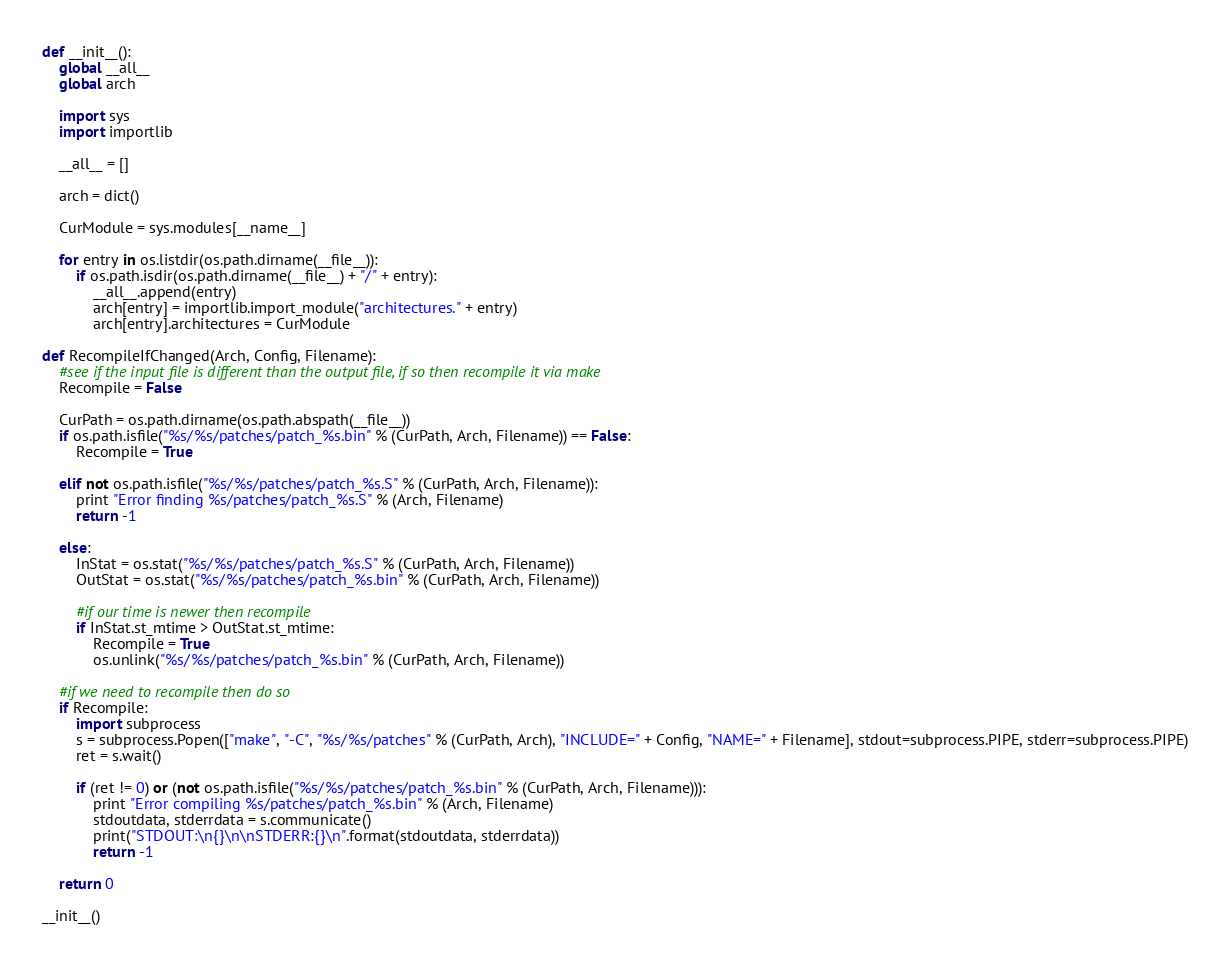Convert code to text. <code><loc_0><loc_0><loc_500><loc_500><_Python_>
def __init__():
    global __all__
    global arch

    import sys
    import importlib

    __all__ = []

    arch = dict()

    CurModule = sys.modules[__name__]

    for entry in os.listdir(os.path.dirname(__file__)):
        if os.path.isdir(os.path.dirname(__file__) + "/" + entry):
            __all__.append(entry)
            arch[entry] = importlib.import_module("architectures." + entry)
            arch[entry].architectures = CurModule

def RecompileIfChanged(Arch, Config, Filename):
    #see if the input file is different than the output file, if so then recompile it via make
    Recompile = False

    CurPath = os.path.dirname(os.path.abspath(__file__))
    if os.path.isfile("%s/%s/patches/patch_%s.bin" % (CurPath, Arch, Filename)) == False:
        Recompile = True

    elif not os.path.isfile("%s/%s/patches/patch_%s.S" % (CurPath, Arch, Filename)):
        print "Error finding %s/patches/patch_%s.S" % (Arch, Filename)
        return -1

    else:
        InStat = os.stat("%s/%s/patches/patch_%s.S" % (CurPath, Arch, Filename))
        OutStat = os.stat("%s/%s/patches/patch_%s.bin" % (CurPath, Arch, Filename))

        #if our time is newer then recompile
        if InStat.st_mtime > OutStat.st_mtime:
            Recompile = True
            os.unlink("%s/%s/patches/patch_%s.bin" % (CurPath, Arch, Filename))

    #if we need to recompile then do so
    if Recompile:
        import subprocess
        s = subprocess.Popen(["make", "-C", "%s/%s/patches" % (CurPath, Arch), "INCLUDE=" + Config, "NAME=" + Filename], stdout=subprocess.PIPE, stderr=subprocess.PIPE)
        ret = s.wait()

        if (ret != 0) or (not os.path.isfile("%s/%s/patches/patch_%s.bin" % (CurPath, Arch, Filename))):
            print "Error compiling %s/patches/patch_%s.bin" % (Arch, Filename)
            stdoutdata, stderrdata = s.communicate()
            print("STDOUT:\n{}\n\nSTDERR:{}\n".format(stdoutdata, stderrdata))
            return -1

    return 0

__init__()
</code> 